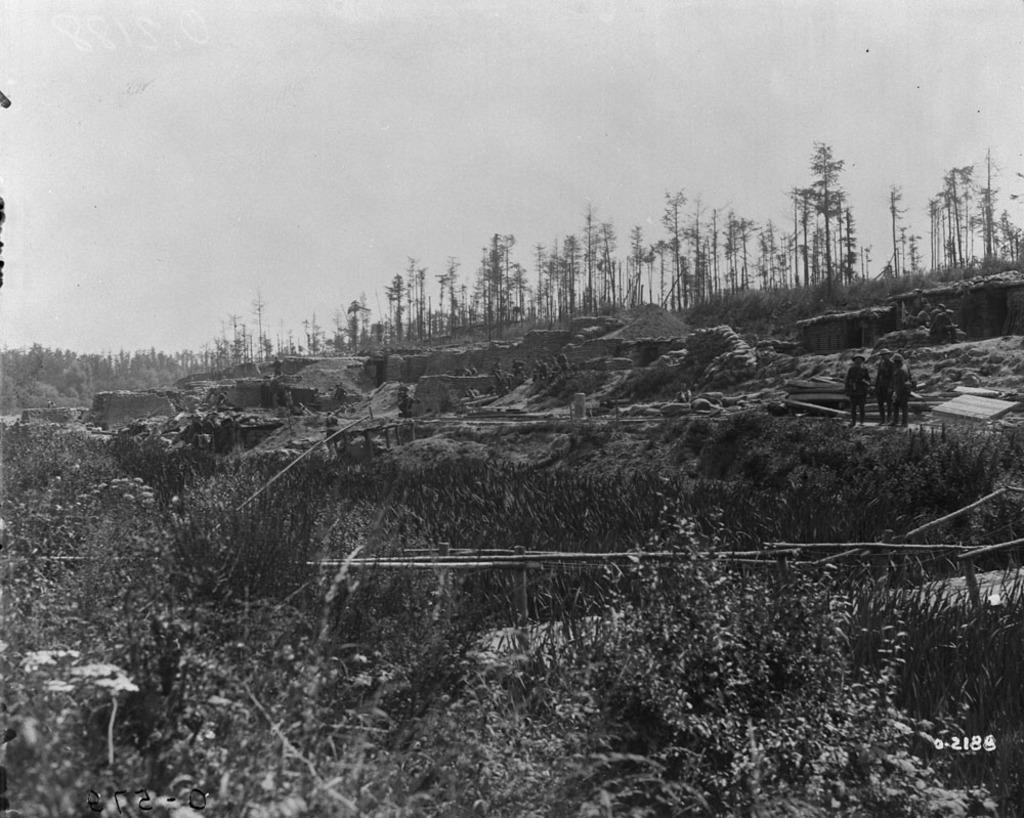Can you describe this image briefly? This image consists of many trees and plants. In the background, there are walls. And there are three persons in this image. At the top, there is a sky. 